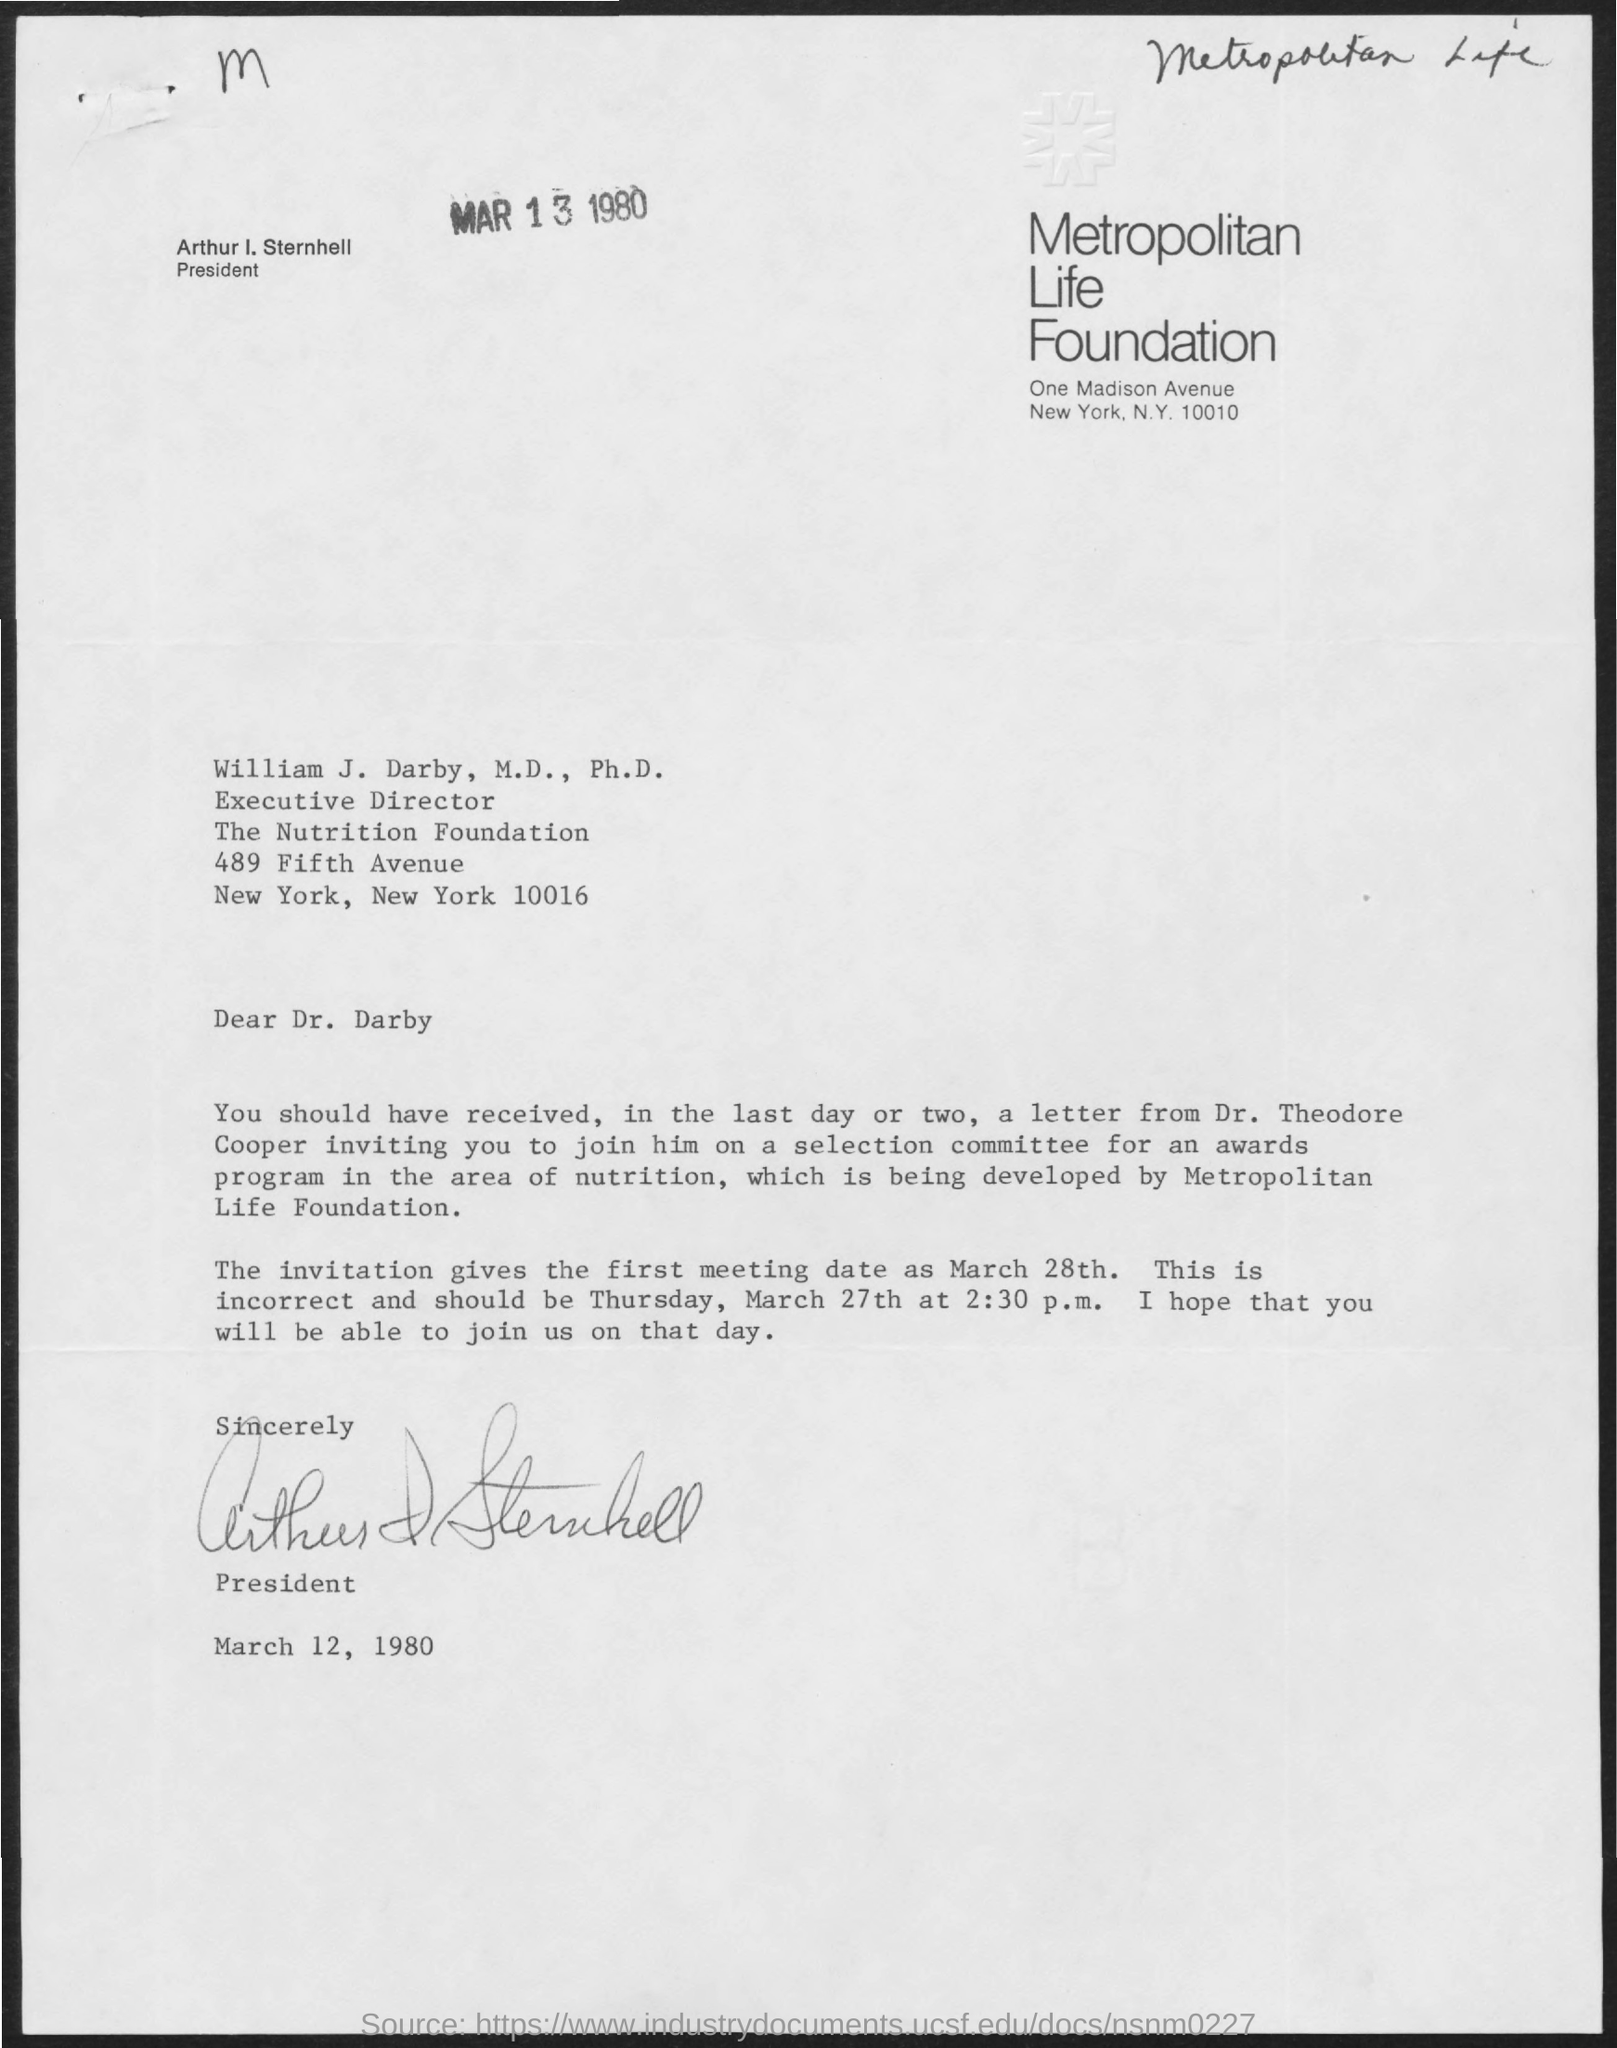Who is the President?
Give a very brief answer. Arthur I. Sternhell. Which letter is at the top-left of the document?
Ensure brevity in your answer.  M. Which date is at the top of the document?
Ensure brevity in your answer.  MAR 13 1980. Which date is at the bottom of the document?
Ensure brevity in your answer.  March 12, 1980. At the top-right of the document, what is written?
Your response must be concise. Metropolitan Life. 